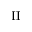Convert formula to latex. <formula><loc_0><loc_0><loc_500><loc_500>I I</formula> 